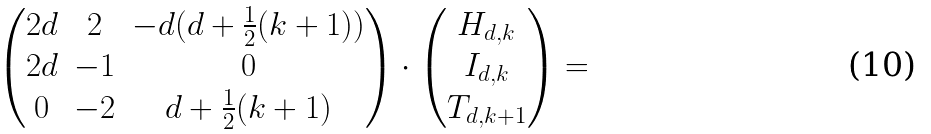<formula> <loc_0><loc_0><loc_500><loc_500>\begin{pmatrix} 2 d & 2 & - d ( d + \frac { 1 } { 2 } ( k + 1 ) ) \\ 2 d & - 1 & 0 \\ 0 & - 2 & d + \frac { 1 } { 2 } ( k + 1 ) \end{pmatrix} \cdot \begin{pmatrix} H _ { d , k } \\ I _ { d , k } \\ T _ { d , k + 1 } \end{pmatrix} =</formula> 